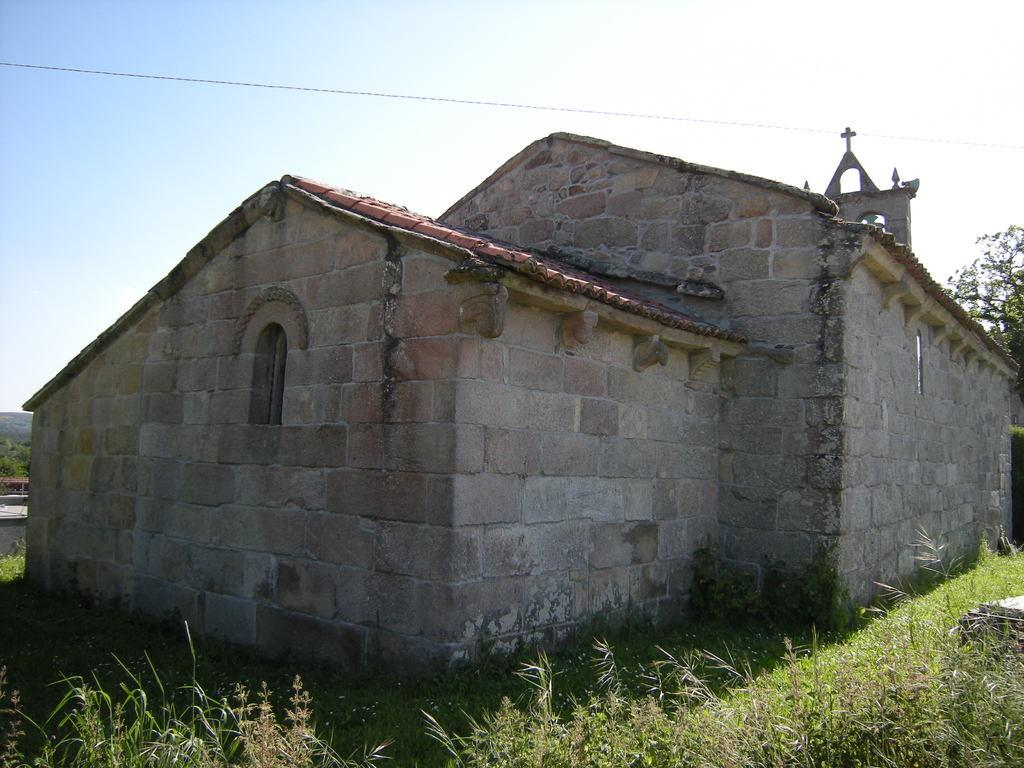What type of vegetation is present on the ground in the front of the image? There is grass on the ground in the front of the image. What structure is located in the center of the image? There is a building in the center of the image. What can be seen in the background of the image? There are trees in the background of the image. How many fans can be seen in the image? There are no fans present in the image. What type of clouds can be seen in the image? There is no mention of clouds in the provided facts, and therefore we cannot determine if any are present in the image. 